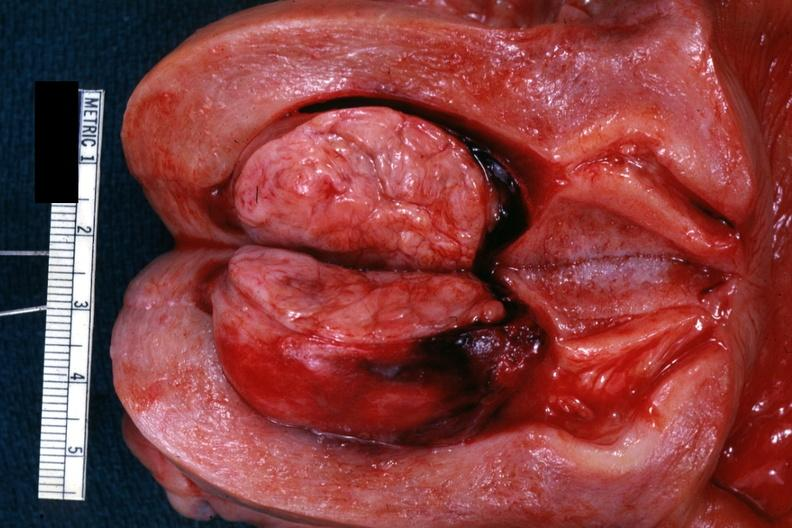what does this image show?
Answer the question using a single word or phrase. Excellent example of submucosal 